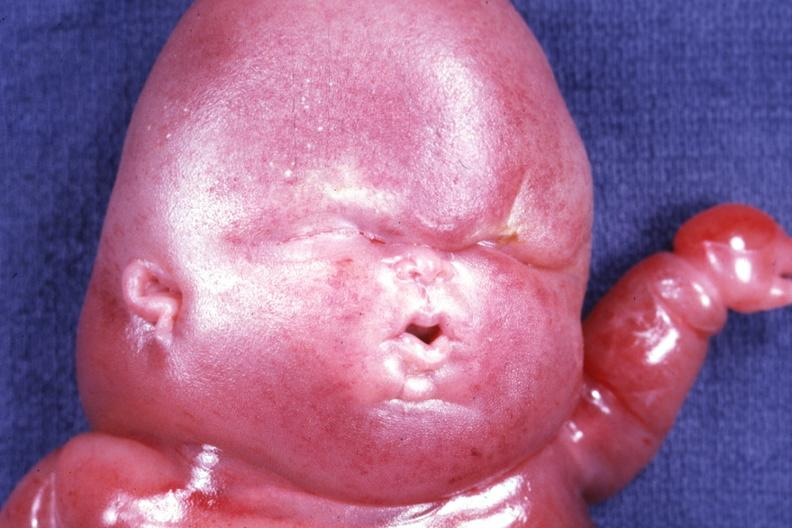s carcinomatosis present?
Answer the question using a single word or phrase. No 